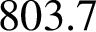Convert formula to latex. <formula><loc_0><loc_0><loc_500><loc_500>8 0 3 . 7</formula> 